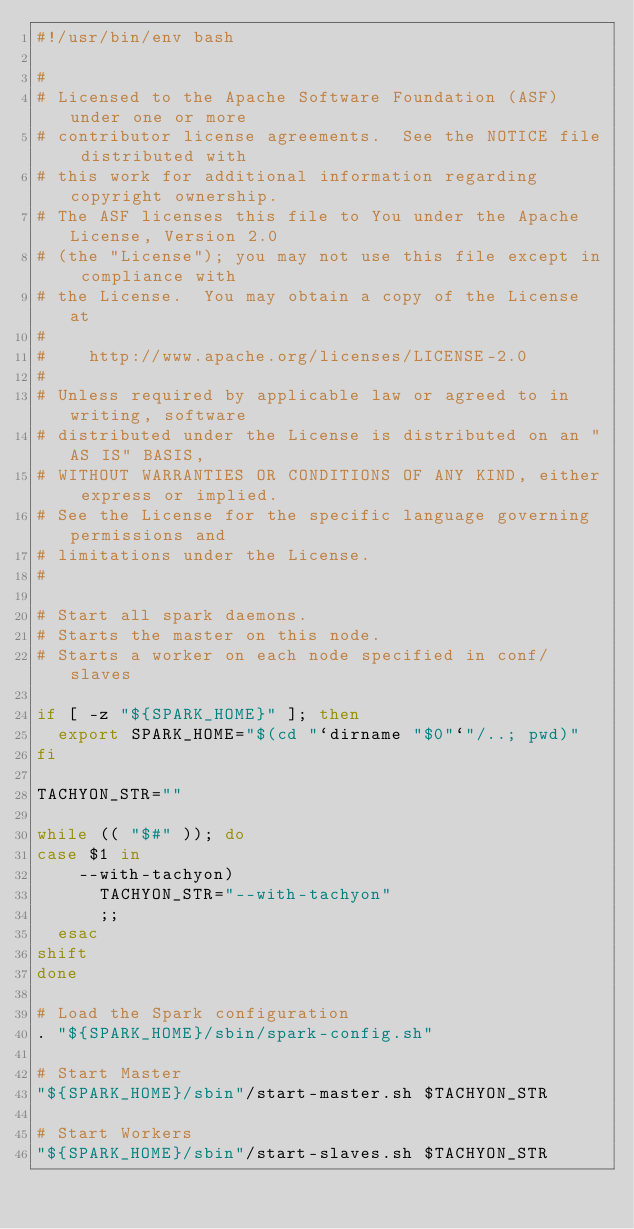Convert code to text. <code><loc_0><loc_0><loc_500><loc_500><_Bash_>#!/usr/bin/env bash

#
# Licensed to the Apache Software Foundation (ASF) under one or more
# contributor license agreements.  See the NOTICE file distributed with
# this work for additional information regarding copyright ownership.
# The ASF licenses this file to You under the Apache License, Version 2.0
# (the "License"); you may not use this file except in compliance with
# the License.  You may obtain a copy of the License at
#
#    http://www.apache.org/licenses/LICENSE-2.0
#
# Unless required by applicable law or agreed to in writing, software
# distributed under the License is distributed on an "AS IS" BASIS,
# WITHOUT WARRANTIES OR CONDITIONS OF ANY KIND, either express or implied.
# See the License for the specific language governing permissions and
# limitations under the License.
#

# Start all spark daemons.
# Starts the master on this node.
# Starts a worker on each node specified in conf/slaves

if [ -z "${SPARK_HOME}" ]; then
  export SPARK_HOME="$(cd "`dirname "$0"`"/..; pwd)"
fi

TACHYON_STR=""

while (( "$#" )); do
case $1 in
    --with-tachyon)
      TACHYON_STR="--with-tachyon"
      ;;
  esac
shift
done

# Load the Spark configuration
. "${SPARK_HOME}/sbin/spark-config.sh"

# Start Master
"${SPARK_HOME}/sbin"/start-master.sh $TACHYON_STR

# Start Workers
"${SPARK_HOME}/sbin"/start-slaves.sh $TACHYON_STR
</code> 